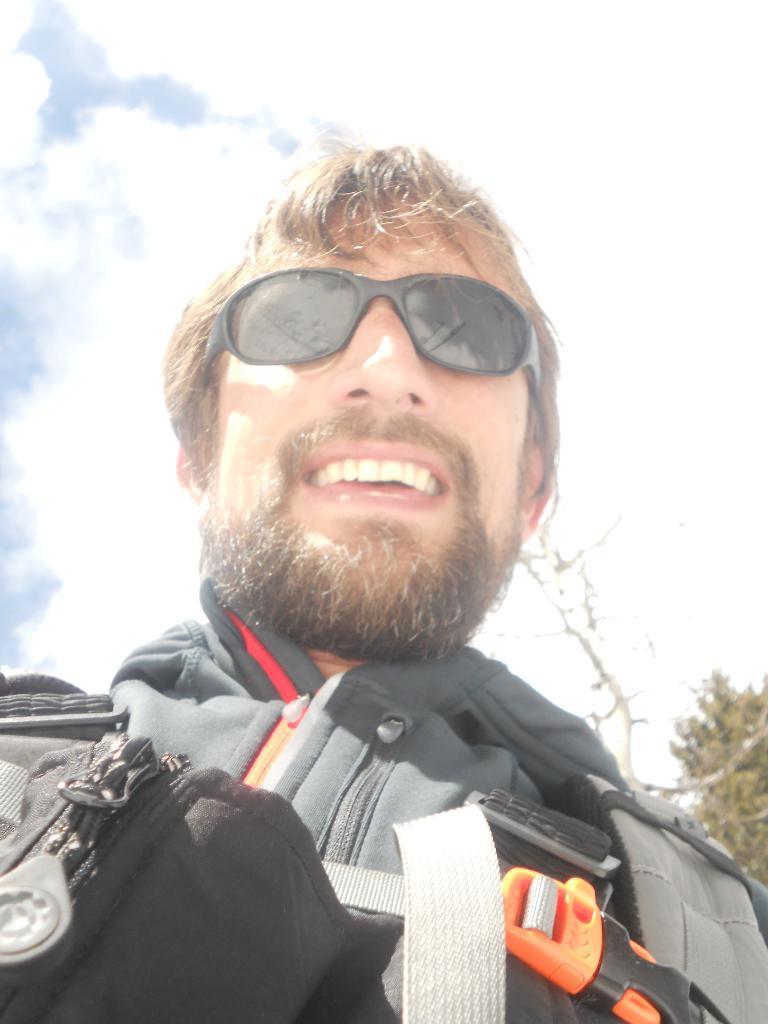How would you summarize this image in a sentence or two? In the image we can see a man wearing clothes and spectacles, and the man is smiling. We can even see a tree and a cloudy sky. 